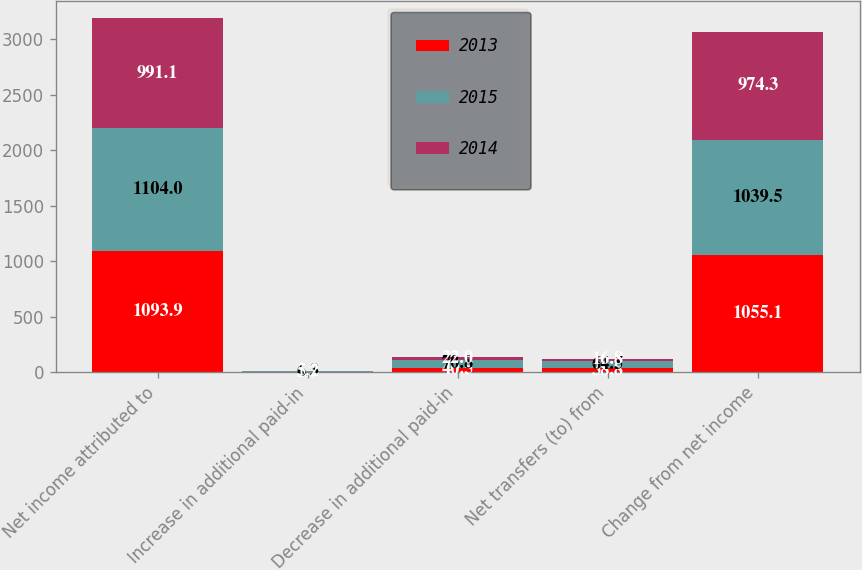<chart> <loc_0><loc_0><loc_500><loc_500><stacked_bar_chart><ecel><fcel>Net income attributed to<fcel>Increase in additional paid-in<fcel>Decrease in additional paid-in<fcel>Net transfers (to) from<fcel>Change from net income<nl><fcel>2013<fcel>1093.9<fcel>1.7<fcel>40.5<fcel>38.8<fcel>1055.1<nl><fcel>2015<fcel>1104<fcel>6.3<fcel>70.8<fcel>64.5<fcel>1039.5<nl><fcel>2014<fcel>991.1<fcel>5.2<fcel>22<fcel>16.8<fcel>974.3<nl></chart> 